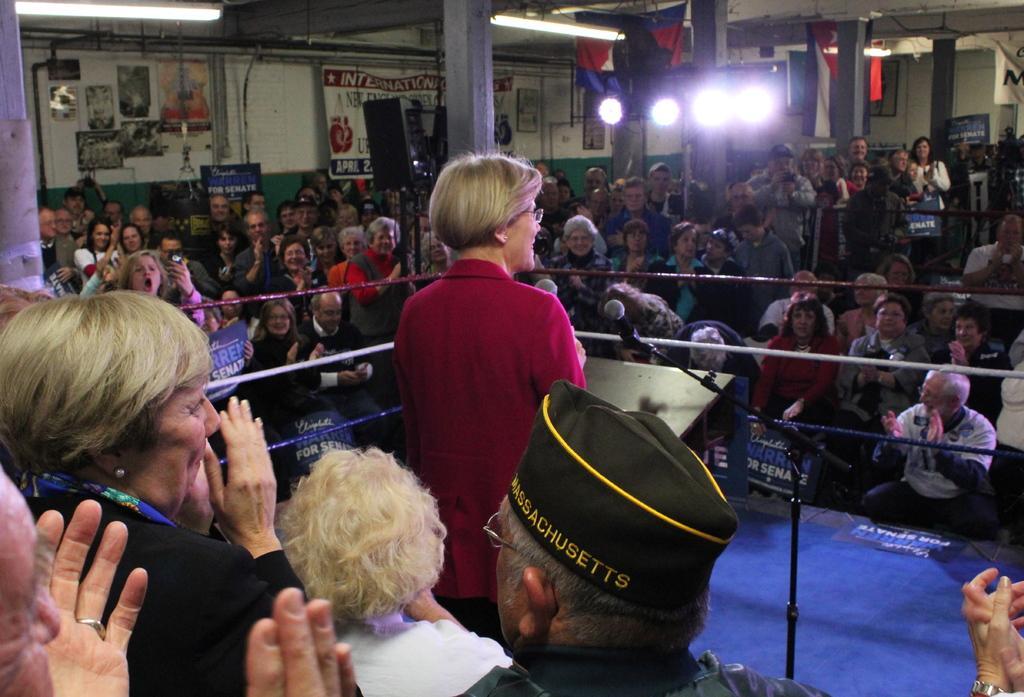How would you summarize this image in a sentence or two? In this picture there is a woman standing and holding the microphone. In the foreground there are group of people and there is a podium and microphone. At the back there are group of people and there are boards on the wall and there are banners and there is text on the boards and on the banners and there are flags and lights and there are pipes on the wall. 